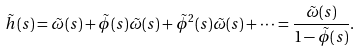<formula> <loc_0><loc_0><loc_500><loc_500>\tilde { h } ( s ) = \tilde { \omega } ( s ) + \tilde { \phi } ( s ) \tilde { \omega } ( s ) + \tilde { \phi } ^ { 2 } ( s ) \tilde { \omega } ( s ) + \dots = \frac { \tilde { \omega } ( s ) } { 1 - \tilde { \phi } ( s ) } .</formula> 